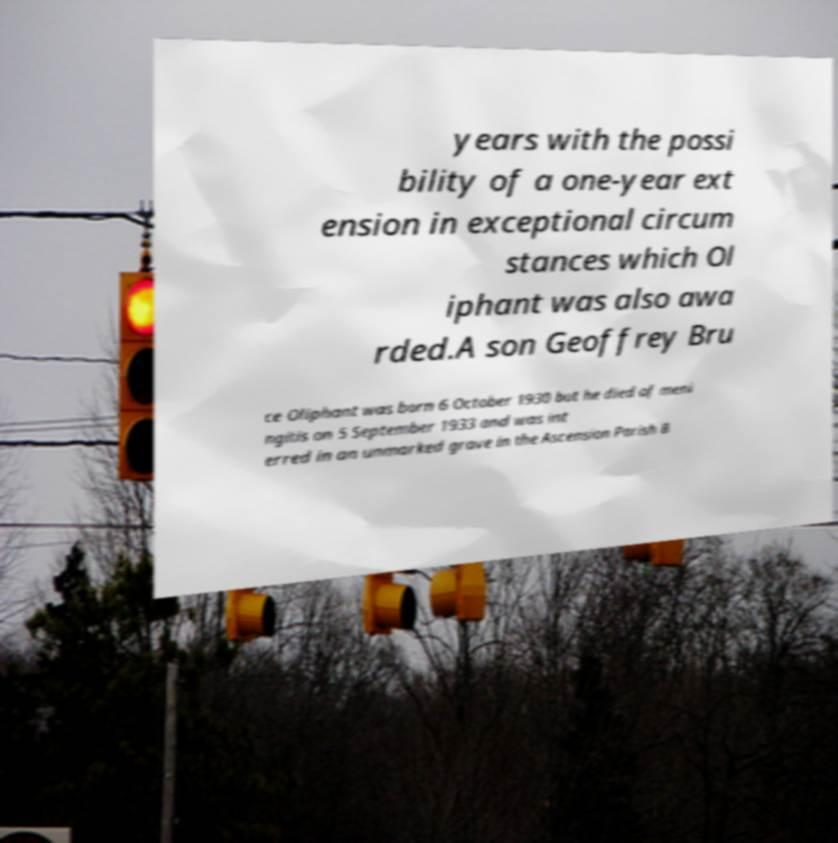Can you accurately transcribe the text from the provided image for me? years with the possi bility of a one-year ext ension in exceptional circum stances which Ol iphant was also awa rded.A son Geoffrey Bru ce Oliphant was born 6 October 1930 but he died of meni ngitis on 5 September 1933 and was int erred in an unmarked grave in the Ascension Parish B 